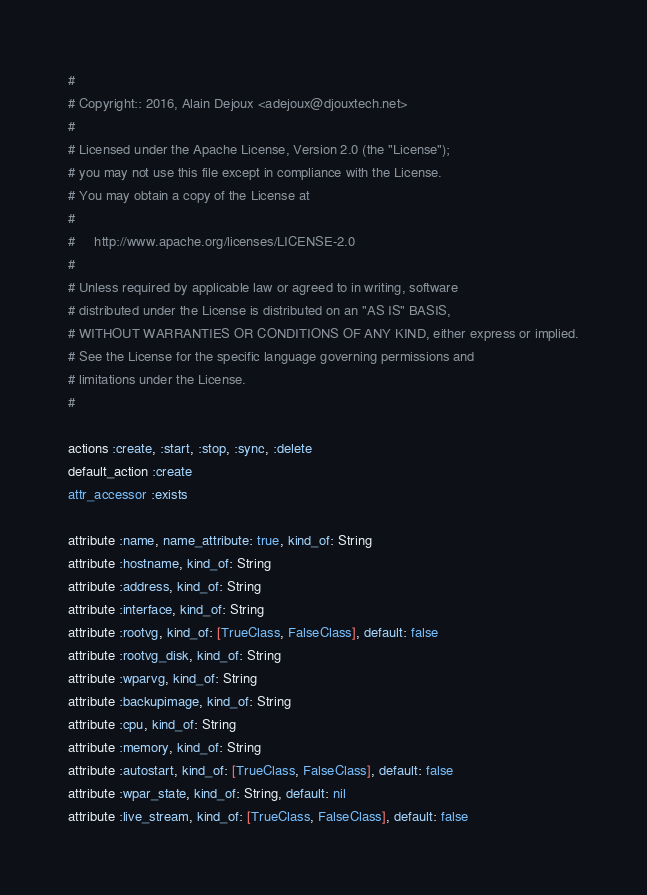Convert code to text. <code><loc_0><loc_0><loc_500><loc_500><_Ruby_>#
# Copyright:: 2016, Alain Dejoux <adejoux@djouxtech.net>
#
# Licensed under the Apache License, Version 2.0 (the "License");
# you may not use this file except in compliance with the License.
# You may obtain a copy of the License at
#
#     http://www.apache.org/licenses/LICENSE-2.0
#
# Unless required by applicable law or agreed to in writing, software
# distributed under the License is distributed on an "AS IS" BASIS,
# WITHOUT WARRANTIES OR CONDITIONS OF ANY KIND, either express or implied.
# See the License for the specific language governing permissions and
# limitations under the License.
#

actions :create, :start, :stop, :sync, :delete
default_action :create
attr_accessor :exists

attribute :name, name_attribute: true, kind_of: String
attribute :hostname, kind_of: String
attribute :address, kind_of: String
attribute :interface, kind_of: String
attribute :rootvg, kind_of: [TrueClass, FalseClass], default: false
attribute :rootvg_disk, kind_of: String
attribute :wparvg, kind_of: String
attribute :backupimage, kind_of: String
attribute :cpu, kind_of: String
attribute :memory, kind_of: String
attribute :autostart, kind_of: [TrueClass, FalseClass], default: false
attribute :wpar_state, kind_of: String, default: nil
attribute :live_stream, kind_of: [TrueClass, FalseClass], default: false
</code> 